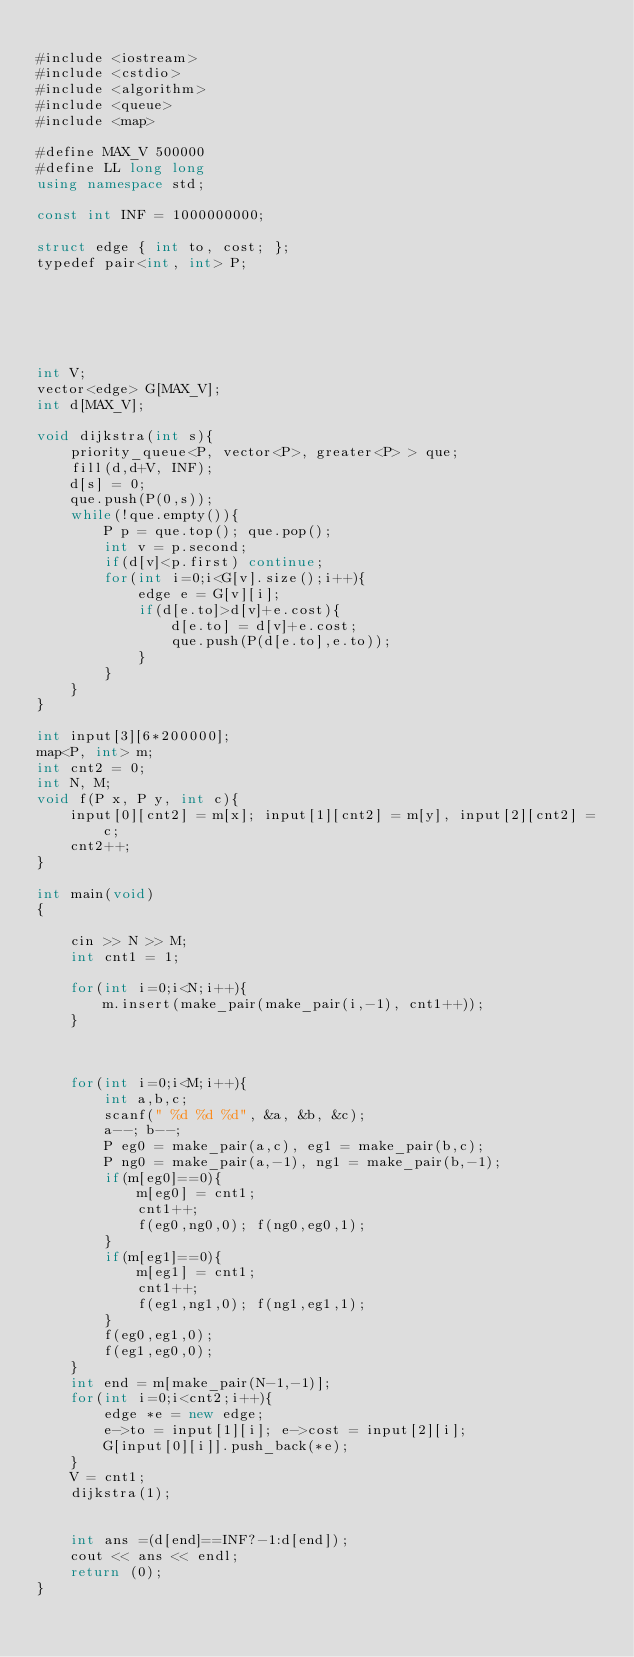<code> <loc_0><loc_0><loc_500><loc_500><_C#_>
#include <iostream>
#include <cstdio>
#include <algorithm>
#include <queue>
#include <map>

#define MAX_V 500000
#define LL long long
using namespace std;

const int INF = 1000000000;

struct edge { int to, cost; };
typedef pair<int, int> P;






int V;
vector<edge> G[MAX_V];
int d[MAX_V];

void dijkstra(int s){
    priority_queue<P, vector<P>, greater<P> > que;
    fill(d,d+V, INF);
    d[s] = 0;
    que.push(P(0,s));
    while(!que.empty()){
        P p = que.top(); que.pop();
        int v = p.second;
        if(d[v]<p.first) continue;
        for(int i=0;i<G[v].size();i++){
            edge e = G[v][i];
            if(d[e.to]>d[v]+e.cost){
                d[e.to] = d[v]+e.cost;
                que.push(P(d[e.to],e.to));
            }
        }
    }
}

int input[3][6*200000];
map<P, int> m;
int cnt2 = 0;
int N, M;
void f(P x, P y, int c){
    input[0][cnt2] = m[x]; input[1][cnt2] = m[y], input[2][cnt2] = c;
    cnt2++; 
}

int main(void)
{
    
    cin >> N >> M;
    int cnt1 = 1;
    
    for(int i=0;i<N;i++){
        m.insert(make_pair(make_pair(i,-1), cnt1++));
    }
    
    
    
    for(int i=0;i<M;i++){
        int a,b,c;
        scanf(" %d %d %d", &a, &b, &c);
        a--; b--;
        P eg0 = make_pair(a,c), eg1 = make_pair(b,c); 
        P ng0 = make_pair(a,-1), ng1 = make_pair(b,-1);
        if(m[eg0]==0){
            m[eg0] = cnt1;
            cnt1++;
            f(eg0,ng0,0); f(ng0,eg0,1);
        }
        if(m[eg1]==0){
            m[eg1] = cnt1;
            cnt1++;
            f(eg1,ng1,0); f(ng1,eg1,1);
        }
        f(eg0,eg1,0);
        f(eg1,eg0,0);
    }
    int end = m[make_pair(N-1,-1)];
    for(int i=0;i<cnt2;i++){
        edge *e = new edge;
        e->to = input[1][i]; e->cost = input[2][i];
        G[input[0][i]].push_back(*e);
    }
    V = cnt1;
    dijkstra(1);
    
    
    int ans =(d[end]==INF?-1:d[end]);
    cout << ans << endl;
    return (0);
}
</code> 